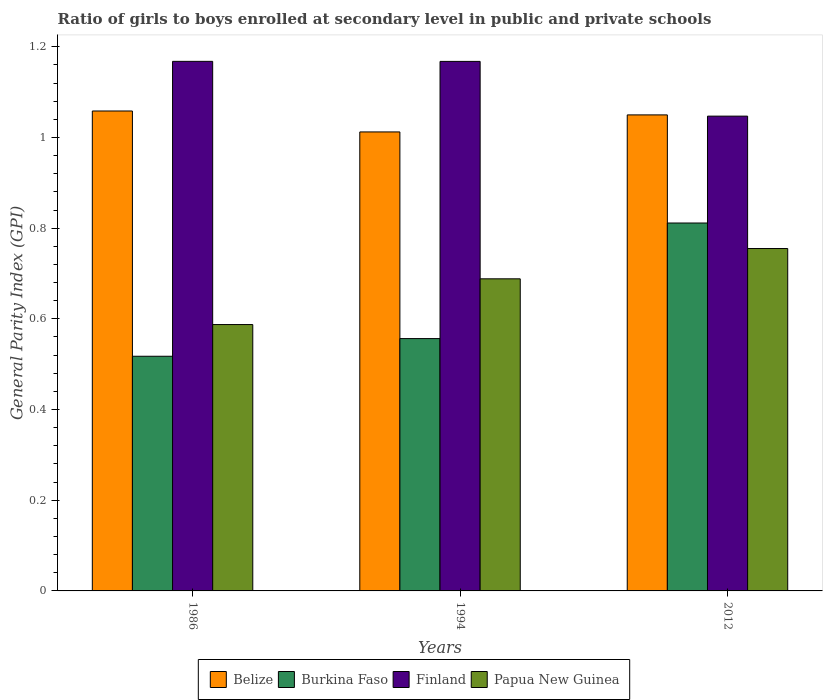Are the number of bars per tick equal to the number of legend labels?
Ensure brevity in your answer.  Yes. Are the number of bars on each tick of the X-axis equal?
Your response must be concise. Yes. What is the general parity index in Belize in 1994?
Keep it short and to the point. 1.01. Across all years, what is the maximum general parity index in Burkina Faso?
Give a very brief answer. 0.81. Across all years, what is the minimum general parity index in Papua New Guinea?
Give a very brief answer. 0.59. In which year was the general parity index in Papua New Guinea maximum?
Provide a succinct answer. 2012. What is the total general parity index in Papua New Guinea in the graph?
Provide a short and direct response. 2.03. What is the difference between the general parity index in Papua New Guinea in 1986 and that in 1994?
Keep it short and to the point. -0.1. What is the difference between the general parity index in Finland in 2012 and the general parity index in Burkina Faso in 1994?
Provide a succinct answer. 0.49. What is the average general parity index in Belize per year?
Give a very brief answer. 1.04. In the year 1994, what is the difference between the general parity index in Finland and general parity index in Papua New Guinea?
Provide a succinct answer. 0.48. What is the ratio of the general parity index in Burkina Faso in 1986 to that in 2012?
Offer a terse response. 0.64. Is the general parity index in Burkina Faso in 1994 less than that in 2012?
Provide a short and direct response. Yes. Is the difference between the general parity index in Finland in 1994 and 2012 greater than the difference between the general parity index in Papua New Guinea in 1994 and 2012?
Make the answer very short. Yes. What is the difference between the highest and the second highest general parity index in Finland?
Provide a succinct answer. 9.999999999998899e-5. What is the difference between the highest and the lowest general parity index in Papua New Guinea?
Give a very brief answer. 0.17. Is it the case that in every year, the sum of the general parity index in Belize and general parity index in Finland is greater than the sum of general parity index in Papua New Guinea and general parity index in Burkina Faso?
Your answer should be compact. Yes. Is it the case that in every year, the sum of the general parity index in Papua New Guinea and general parity index in Burkina Faso is greater than the general parity index in Finland?
Keep it short and to the point. No. How many bars are there?
Ensure brevity in your answer.  12. Are all the bars in the graph horizontal?
Offer a terse response. No. How many years are there in the graph?
Your answer should be compact. 3. Are the values on the major ticks of Y-axis written in scientific E-notation?
Your response must be concise. No. Does the graph contain grids?
Give a very brief answer. No. What is the title of the graph?
Your answer should be compact. Ratio of girls to boys enrolled at secondary level in public and private schools. Does "Malaysia" appear as one of the legend labels in the graph?
Offer a terse response. No. What is the label or title of the Y-axis?
Make the answer very short. General Parity Index (GPI). What is the General Parity Index (GPI) in Belize in 1986?
Your answer should be compact. 1.06. What is the General Parity Index (GPI) of Burkina Faso in 1986?
Your answer should be compact. 0.52. What is the General Parity Index (GPI) in Finland in 1986?
Give a very brief answer. 1.17. What is the General Parity Index (GPI) in Papua New Guinea in 1986?
Give a very brief answer. 0.59. What is the General Parity Index (GPI) in Belize in 1994?
Offer a terse response. 1.01. What is the General Parity Index (GPI) in Burkina Faso in 1994?
Provide a succinct answer. 0.56. What is the General Parity Index (GPI) in Finland in 1994?
Offer a terse response. 1.17. What is the General Parity Index (GPI) in Papua New Guinea in 1994?
Provide a succinct answer. 0.69. What is the General Parity Index (GPI) in Belize in 2012?
Offer a terse response. 1.05. What is the General Parity Index (GPI) of Burkina Faso in 2012?
Provide a succinct answer. 0.81. What is the General Parity Index (GPI) in Finland in 2012?
Provide a succinct answer. 1.05. What is the General Parity Index (GPI) of Papua New Guinea in 2012?
Your response must be concise. 0.76. Across all years, what is the maximum General Parity Index (GPI) in Belize?
Provide a short and direct response. 1.06. Across all years, what is the maximum General Parity Index (GPI) in Burkina Faso?
Give a very brief answer. 0.81. Across all years, what is the maximum General Parity Index (GPI) of Finland?
Provide a short and direct response. 1.17. Across all years, what is the maximum General Parity Index (GPI) of Papua New Guinea?
Provide a short and direct response. 0.76. Across all years, what is the minimum General Parity Index (GPI) of Belize?
Your answer should be compact. 1.01. Across all years, what is the minimum General Parity Index (GPI) in Burkina Faso?
Offer a very short reply. 0.52. Across all years, what is the minimum General Parity Index (GPI) in Finland?
Make the answer very short. 1.05. Across all years, what is the minimum General Parity Index (GPI) of Papua New Guinea?
Ensure brevity in your answer.  0.59. What is the total General Parity Index (GPI) in Belize in the graph?
Your answer should be compact. 3.12. What is the total General Parity Index (GPI) of Burkina Faso in the graph?
Ensure brevity in your answer.  1.89. What is the total General Parity Index (GPI) of Finland in the graph?
Your answer should be very brief. 3.38. What is the total General Parity Index (GPI) in Papua New Guinea in the graph?
Your answer should be very brief. 2.03. What is the difference between the General Parity Index (GPI) in Belize in 1986 and that in 1994?
Ensure brevity in your answer.  0.05. What is the difference between the General Parity Index (GPI) in Burkina Faso in 1986 and that in 1994?
Make the answer very short. -0.04. What is the difference between the General Parity Index (GPI) of Papua New Guinea in 1986 and that in 1994?
Provide a succinct answer. -0.1. What is the difference between the General Parity Index (GPI) of Belize in 1986 and that in 2012?
Ensure brevity in your answer.  0.01. What is the difference between the General Parity Index (GPI) of Burkina Faso in 1986 and that in 2012?
Offer a very short reply. -0.29. What is the difference between the General Parity Index (GPI) of Finland in 1986 and that in 2012?
Your response must be concise. 0.12. What is the difference between the General Parity Index (GPI) in Papua New Guinea in 1986 and that in 2012?
Offer a terse response. -0.17. What is the difference between the General Parity Index (GPI) in Belize in 1994 and that in 2012?
Offer a very short reply. -0.04. What is the difference between the General Parity Index (GPI) in Burkina Faso in 1994 and that in 2012?
Provide a short and direct response. -0.25. What is the difference between the General Parity Index (GPI) in Finland in 1994 and that in 2012?
Your response must be concise. 0.12. What is the difference between the General Parity Index (GPI) in Papua New Guinea in 1994 and that in 2012?
Provide a succinct answer. -0.07. What is the difference between the General Parity Index (GPI) in Belize in 1986 and the General Parity Index (GPI) in Burkina Faso in 1994?
Provide a short and direct response. 0.5. What is the difference between the General Parity Index (GPI) of Belize in 1986 and the General Parity Index (GPI) of Finland in 1994?
Offer a terse response. -0.11. What is the difference between the General Parity Index (GPI) in Belize in 1986 and the General Parity Index (GPI) in Papua New Guinea in 1994?
Provide a short and direct response. 0.37. What is the difference between the General Parity Index (GPI) of Burkina Faso in 1986 and the General Parity Index (GPI) of Finland in 1994?
Your answer should be very brief. -0.65. What is the difference between the General Parity Index (GPI) of Burkina Faso in 1986 and the General Parity Index (GPI) of Papua New Guinea in 1994?
Ensure brevity in your answer.  -0.17. What is the difference between the General Parity Index (GPI) of Finland in 1986 and the General Parity Index (GPI) of Papua New Guinea in 1994?
Give a very brief answer. 0.48. What is the difference between the General Parity Index (GPI) of Belize in 1986 and the General Parity Index (GPI) of Burkina Faso in 2012?
Provide a short and direct response. 0.25. What is the difference between the General Parity Index (GPI) of Belize in 1986 and the General Parity Index (GPI) of Finland in 2012?
Offer a terse response. 0.01. What is the difference between the General Parity Index (GPI) in Belize in 1986 and the General Parity Index (GPI) in Papua New Guinea in 2012?
Offer a terse response. 0.3. What is the difference between the General Parity Index (GPI) in Burkina Faso in 1986 and the General Parity Index (GPI) in Finland in 2012?
Make the answer very short. -0.53. What is the difference between the General Parity Index (GPI) of Burkina Faso in 1986 and the General Parity Index (GPI) of Papua New Guinea in 2012?
Ensure brevity in your answer.  -0.24. What is the difference between the General Parity Index (GPI) in Finland in 1986 and the General Parity Index (GPI) in Papua New Guinea in 2012?
Ensure brevity in your answer.  0.41. What is the difference between the General Parity Index (GPI) of Belize in 1994 and the General Parity Index (GPI) of Burkina Faso in 2012?
Ensure brevity in your answer.  0.2. What is the difference between the General Parity Index (GPI) in Belize in 1994 and the General Parity Index (GPI) in Finland in 2012?
Offer a very short reply. -0.03. What is the difference between the General Parity Index (GPI) of Belize in 1994 and the General Parity Index (GPI) of Papua New Guinea in 2012?
Give a very brief answer. 0.26. What is the difference between the General Parity Index (GPI) of Burkina Faso in 1994 and the General Parity Index (GPI) of Finland in 2012?
Provide a short and direct response. -0.49. What is the difference between the General Parity Index (GPI) in Burkina Faso in 1994 and the General Parity Index (GPI) in Papua New Guinea in 2012?
Provide a succinct answer. -0.2. What is the difference between the General Parity Index (GPI) in Finland in 1994 and the General Parity Index (GPI) in Papua New Guinea in 2012?
Give a very brief answer. 0.41. What is the average General Parity Index (GPI) in Belize per year?
Offer a very short reply. 1.04. What is the average General Parity Index (GPI) of Burkina Faso per year?
Provide a succinct answer. 0.63. What is the average General Parity Index (GPI) of Finland per year?
Provide a short and direct response. 1.13. What is the average General Parity Index (GPI) in Papua New Guinea per year?
Your answer should be very brief. 0.68. In the year 1986, what is the difference between the General Parity Index (GPI) of Belize and General Parity Index (GPI) of Burkina Faso?
Your response must be concise. 0.54. In the year 1986, what is the difference between the General Parity Index (GPI) in Belize and General Parity Index (GPI) in Finland?
Give a very brief answer. -0.11. In the year 1986, what is the difference between the General Parity Index (GPI) in Belize and General Parity Index (GPI) in Papua New Guinea?
Your response must be concise. 0.47. In the year 1986, what is the difference between the General Parity Index (GPI) in Burkina Faso and General Parity Index (GPI) in Finland?
Offer a very short reply. -0.65. In the year 1986, what is the difference between the General Parity Index (GPI) of Burkina Faso and General Parity Index (GPI) of Papua New Guinea?
Your response must be concise. -0.07. In the year 1986, what is the difference between the General Parity Index (GPI) of Finland and General Parity Index (GPI) of Papua New Guinea?
Ensure brevity in your answer.  0.58. In the year 1994, what is the difference between the General Parity Index (GPI) in Belize and General Parity Index (GPI) in Burkina Faso?
Provide a succinct answer. 0.46. In the year 1994, what is the difference between the General Parity Index (GPI) of Belize and General Parity Index (GPI) of Finland?
Keep it short and to the point. -0.16. In the year 1994, what is the difference between the General Parity Index (GPI) of Belize and General Parity Index (GPI) of Papua New Guinea?
Keep it short and to the point. 0.32. In the year 1994, what is the difference between the General Parity Index (GPI) of Burkina Faso and General Parity Index (GPI) of Finland?
Provide a short and direct response. -0.61. In the year 1994, what is the difference between the General Parity Index (GPI) of Burkina Faso and General Parity Index (GPI) of Papua New Guinea?
Provide a succinct answer. -0.13. In the year 1994, what is the difference between the General Parity Index (GPI) of Finland and General Parity Index (GPI) of Papua New Guinea?
Your response must be concise. 0.48. In the year 2012, what is the difference between the General Parity Index (GPI) in Belize and General Parity Index (GPI) in Burkina Faso?
Provide a short and direct response. 0.24. In the year 2012, what is the difference between the General Parity Index (GPI) in Belize and General Parity Index (GPI) in Finland?
Give a very brief answer. 0. In the year 2012, what is the difference between the General Parity Index (GPI) in Belize and General Parity Index (GPI) in Papua New Guinea?
Your response must be concise. 0.29. In the year 2012, what is the difference between the General Parity Index (GPI) in Burkina Faso and General Parity Index (GPI) in Finland?
Ensure brevity in your answer.  -0.24. In the year 2012, what is the difference between the General Parity Index (GPI) of Burkina Faso and General Parity Index (GPI) of Papua New Guinea?
Your response must be concise. 0.06. In the year 2012, what is the difference between the General Parity Index (GPI) of Finland and General Parity Index (GPI) of Papua New Guinea?
Your answer should be very brief. 0.29. What is the ratio of the General Parity Index (GPI) in Belize in 1986 to that in 1994?
Ensure brevity in your answer.  1.05. What is the ratio of the General Parity Index (GPI) in Finland in 1986 to that in 1994?
Offer a very short reply. 1. What is the ratio of the General Parity Index (GPI) in Papua New Guinea in 1986 to that in 1994?
Give a very brief answer. 0.85. What is the ratio of the General Parity Index (GPI) in Belize in 1986 to that in 2012?
Keep it short and to the point. 1.01. What is the ratio of the General Parity Index (GPI) of Burkina Faso in 1986 to that in 2012?
Offer a terse response. 0.64. What is the ratio of the General Parity Index (GPI) of Finland in 1986 to that in 2012?
Your answer should be compact. 1.12. What is the ratio of the General Parity Index (GPI) in Papua New Guinea in 1986 to that in 2012?
Provide a short and direct response. 0.78. What is the ratio of the General Parity Index (GPI) of Belize in 1994 to that in 2012?
Give a very brief answer. 0.96. What is the ratio of the General Parity Index (GPI) in Burkina Faso in 1994 to that in 2012?
Your answer should be compact. 0.69. What is the ratio of the General Parity Index (GPI) of Finland in 1994 to that in 2012?
Offer a very short reply. 1.12. What is the ratio of the General Parity Index (GPI) of Papua New Guinea in 1994 to that in 2012?
Your response must be concise. 0.91. What is the difference between the highest and the second highest General Parity Index (GPI) of Belize?
Ensure brevity in your answer.  0.01. What is the difference between the highest and the second highest General Parity Index (GPI) in Burkina Faso?
Make the answer very short. 0.25. What is the difference between the highest and the second highest General Parity Index (GPI) of Papua New Guinea?
Keep it short and to the point. 0.07. What is the difference between the highest and the lowest General Parity Index (GPI) of Belize?
Keep it short and to the point. 0.05. What is the difference between the highest and the lowest General Parity Index (GPI) in Burkina Faso?
Your response must be concise. 0.29. What is the difference between the highest and the lowest General Parity Index (GPI) of Finland?
Ensure brevity in your answer.  0.12. What is the difference between the highest and the lowest General Parity Index (GPI) in Papua New Guinea?
Your response must be concise. 0.17. 